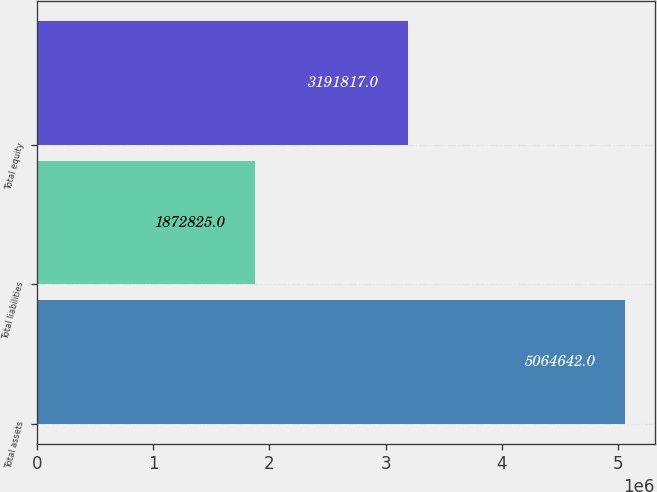Convert chart. <chart><loc_0><loc_0><loc_500><loc_500><bar_chart><fcel>Total assets<fcel>Total liabilities<fcel>Total equity<nl><fcel>5.06464e+06<fcel>1.87282e+06<fcel>3.19182e+06<nl></chart> 